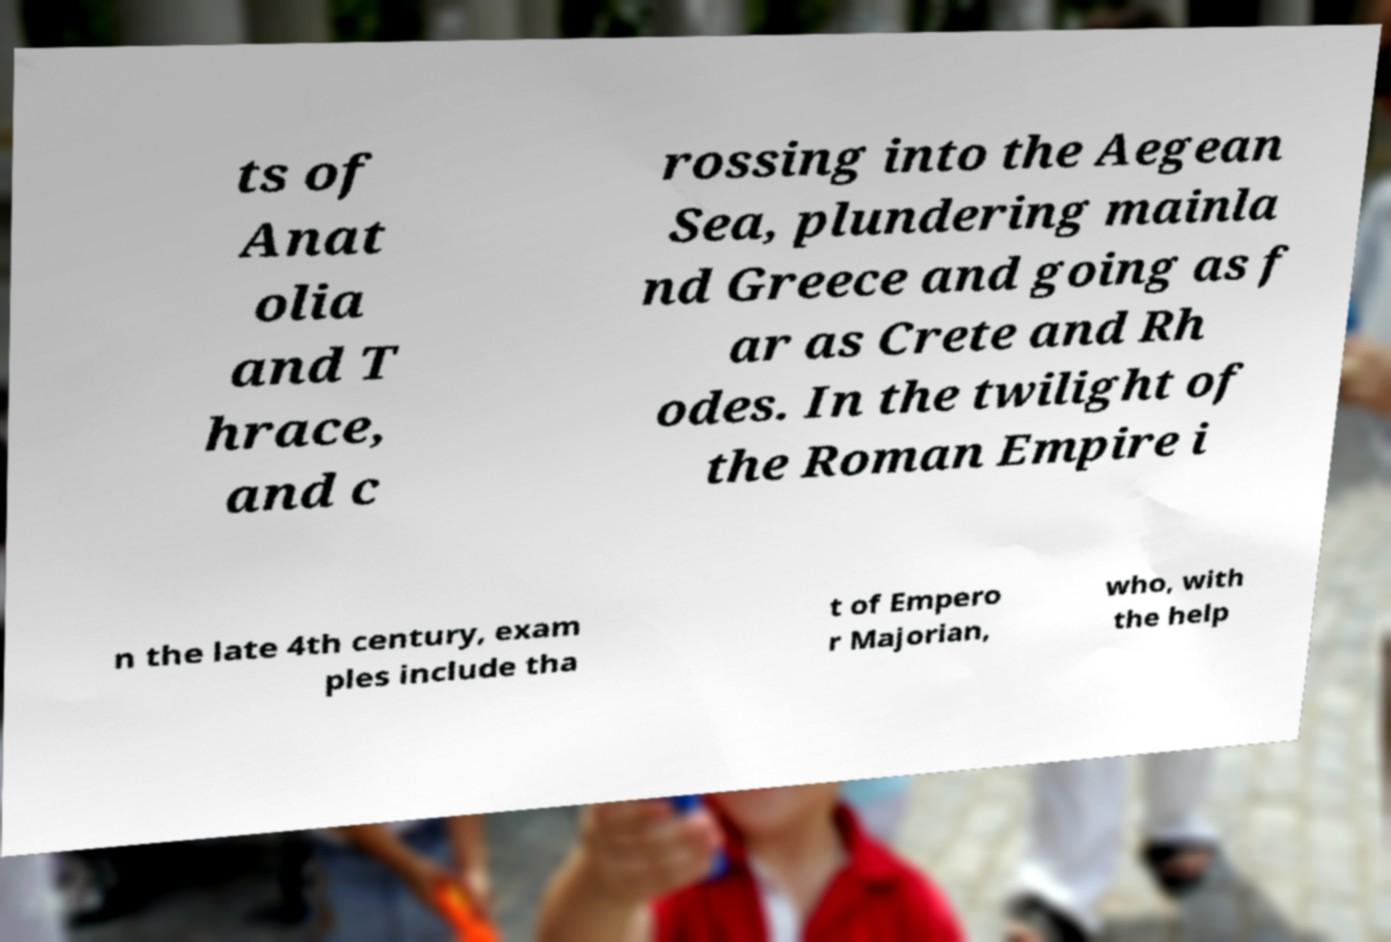What messages or text are displayed in this image? I need them in a readable, typed format. ts of Anat olia and T hrace, and c rossing into the Aegean Sea, plundering mainla nd Greece and going as f ar as Crete and Rh odes. In the twilight of the Roman Empire i n the late 4th century, exam ples include tha t of Empero r Majorian, who, with the help 